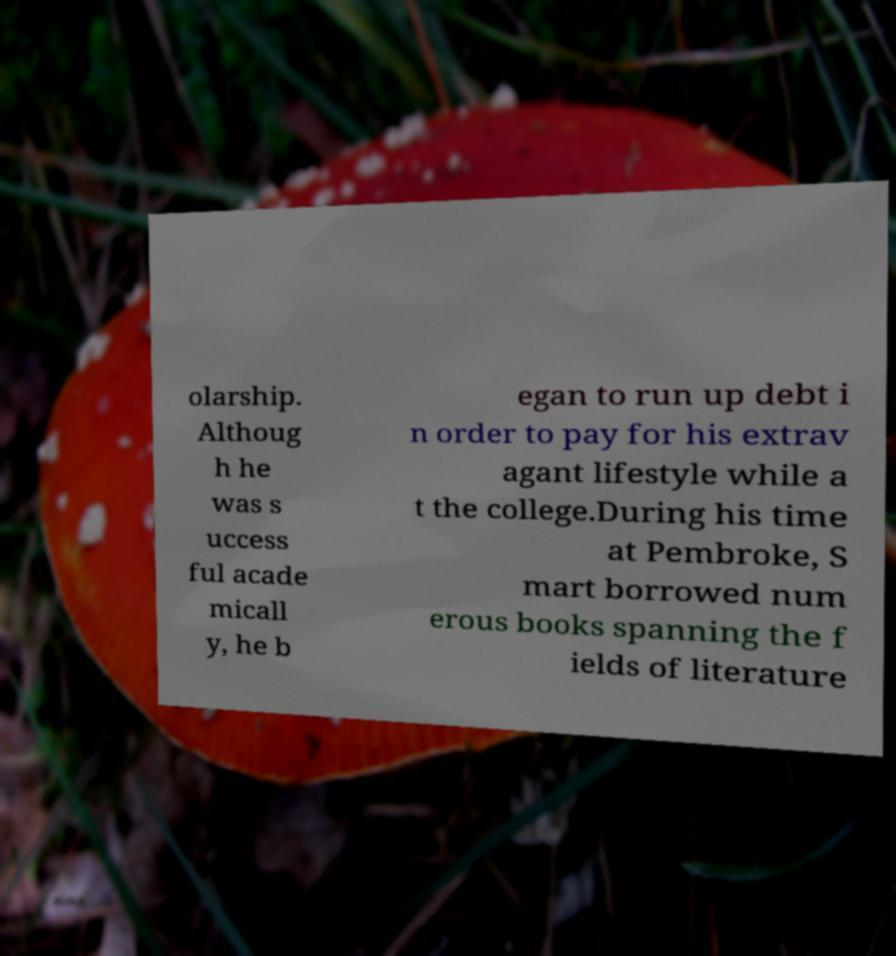Can you accurately transcribe the text from the provided image for me? olarship. Althoug h he was s uccess ful acade micall y, he b egan to run up debt i n order to pay for his extrav agant lifestyle while a t the college.During his time at Pembroke, S mart borrowed num erous books spanning the f ields of literature 